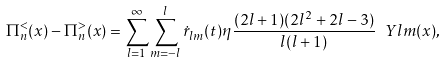<formula> <loc_0><loc_0><loc_500><loc_500>\Pi _ { n } ^ { < } ( x ) - \Pi _ { n } ^ { > } ( x ) = \sum _ { l = 1 } ^ { \infty } \sum _ { m = - l } ^ { l } \dot { r } _ { l m } ( t ) \eta \frac { ( 2 l + 1 ) ( 2 l ^ { 2 } + 2 l - 3 ) } { l ( l + 1 ) } \ Y l m ( x ) ,</formula> 